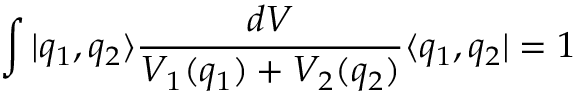Convert formula to latex. <formula><loc_0><loc_0><loc_500><loc_500>\int | q _ { 1 } , q _ { 2 } \rangle \frac { d V } { V _ { 1 } ( q _ { 1 } ) + V _ { 2 } ( q _ { 2 } ) } \langle q _ { 1 } , q _ { 2 } | = 1</formula> 